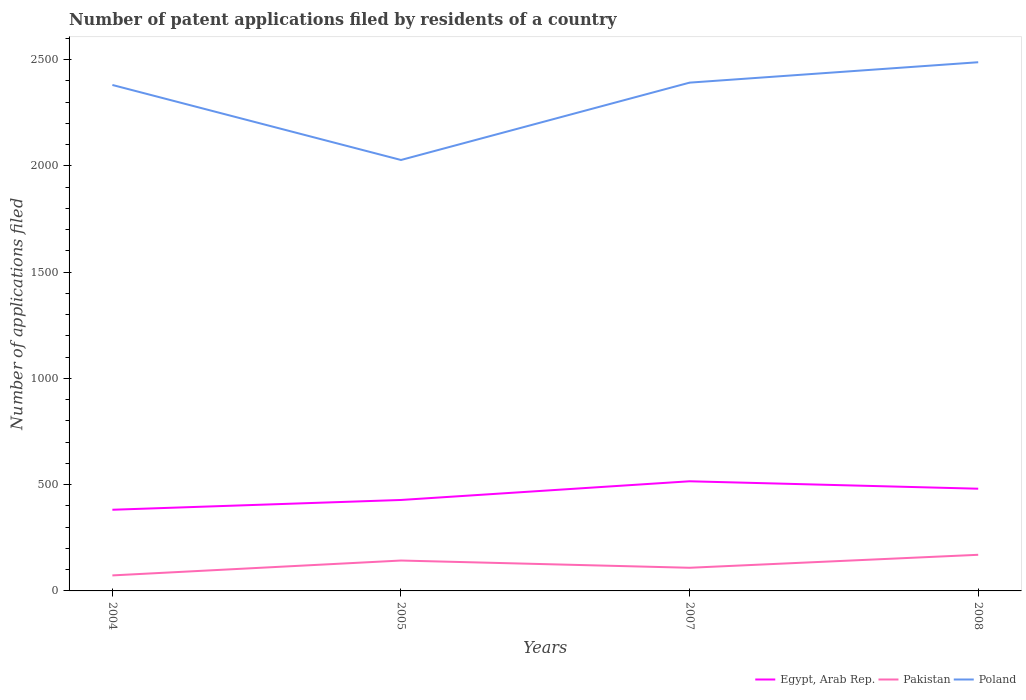How many different coloured lines are there?
Offer a very short reply. 3. Is the number of lines equal to the number of legend labels?
Keep it short and to the point. Yes. Across all years, what is the maximum number of applications filed in Poland?
Offer a terse response. 2028. In which year was the number of applications filed in Pakistan maximum?
Ensure brevity in your answer.  2004. What is the total number of applications filed in Egypt, Arab Rep. in the graph?
Your response must be concise. -134. What is the difference between the highest and the second highest number of applications filed in Egypt, Arab Rep.?
Make the answer very short. 134. What is the difference between the highest and the lowest number of applications filed in Pakistan?
Provide a succinct answer. 2. Is the number of applications filed in Egypt, Arab Rep. strictly greater than the number of applications filed in Pakistan over the years?
Your answer should be compact. No. Does the graph contain any zero values?
Ensure brevity in your answer.  No. Where does the legend appear in the graph?
Give a very brief answer. Bottom right. How many legend labels are there?
Your answer should be compact. 3. What is the title of the graph?
Give a very brief answer. Number of patent applications filed by residents of a country. Does "Lebanon" appear as one of the legend labels in the graph?
Your response must be concise. No. What is the label or title of the Y-axis?
Give a very brief answer. Number of applications filed. What is the Number of applications filed of Egypt, Arab Rep. in 2004?
Keep it short and to the point. 382. What is the Number of applications filed in Pakistan in 2004?
Provide a short and direct response. 73. What is the Number of applications filed in Poland in 2004?
Offer a very short reply. 2381. What is the Number of applications filed of Egypt, Arab Rep. in 2005?
Offer a terse response. 428. What is the Number of applications filed in Pakistan in 2005?
Make the answer very short. 143. What is the Number of applications filed of Poland in 2005?
Provide a short and direct response. 2028. What is the Number of applications filed of Egypt, Arab Rep. in 2007?
Your response must be concise. 516. What is the Number of applications filed in Pakistan in 2007?
Your answer should be very brief. 109. What is the Number of applications filed in Poland in 2007?
Offer a terse response. 2392. What is the Number of applications filed in Egypt, Arab Rep. in 2008?
Offer a very short reply. 481. What is the Number of applications filed in Pakistan in 2008?
Ensure brevity in your answer.  170. What is the Number of applications filed of Poland in 2008?
Provide a succinct answer. 2488. Across all years, what is the maximum Number of applications filed in Egypt, Arab Rep.?
Offer a terse response. 516. Across all years, what is the maximum Number of applications filed of Pakistan?
Ensure brevity in your answer.  170. Across all years, what is the maximum Number of applications filed of Poland?
Ensure brevity in your answer.  2488. Across all years, what is the minimum Number of applications filed of Egypt, Arab Rep.?
Your answer should be very brief. 382. Across all years, what is the minimum Number of applications filed in Pakistan?
Offer a terse response. 73. Across all years, what is the minimum Number of applications filed in Poland?
Provide a short and direct response. 2028. What is the total Number of applications filed of Egypt, Arab Rep. in the graph?
Your response must be concise. 1807. What is the total Number of applications filed in Pakistan in the graph?
Make the answer very short. 495. What is the total Number of applications filed in Poland in the graph?
Ensure brevity in your answer.  9289. What is the difference between the Number of applications filed of Egypt, Arab Rep. in 2004 and that in 2005?
Keep it short and to the point. -46. What is the difference between the Number of applications filed in Pakistan in 2004 and that in 2005?
Provide a succinct answer. -70. What is the difference between the Number of applications filed of Poland in 2004 and that in 2005?
Offer a very short reply. 353. What is the difference between the Number of applications filed of Egypt, Arab Rep. in 2004 and that in 2007?
Offer a terse response. -134. What is the difference between the Number of applications filed in Pakistan in 2004 and that in 2007?
Give a very brief answer. -36. What is the difference between the Number of applications filed in Poland in 2004 and that in 2007?
Provide a succinct answer. -11. What is the difference between the Number of applications filed in Egypt, Arab Rep. in 2004 and that in 2008?
Ensure brevity in your answer.  -99. What is the difference between the Number of applications filed in Pakistan in 2004 and that in 2008?
Keep it short and to the point. -97. What is the difference between the Number of applications filed in Poland in 2004 and that in 2008?
Your answer should be very brief. -107. What is the difference between the Number of applications filed in Egypt, Arab Rep. in 2005 and that in 2007?
Provide a short and direct response. -88. What is the difference between the Number of applications filed of Pakistan in 2005 and that in 2007?
Ensure brevity in your answer.  34. What is the difference between the Number of applications filed of Poland in 2005 and that in 2007?
Your answer should be compact. -364. What is the difference between the Number of applications filed in Egypt, Arab Rep. in 2005 and that in 2008?
Offer a terse response. -53. What is the difference between the Number of applications filed of Poland in 2005 and that in 2008?
Your answer should be compact. -460. What is the difference between the Number of applications filed in Pakistan in 2007 and that in 2008?
Give a very brief answer. -61. What is the difference between the Number of applications filed in Poland in 2007 and that in 2008?
Offer a very short reply. -96. What is the difference between the Number of applications filed of Egypt, Arab Rep. in 2004 and the Number of applications filed of Pakistan in 2005?
Offer a very short reply. 239. What is the difference between the Number of applications filed of Egypt, Arab Rep. in 2004 and the Number of applications filed of Poland in 2005?
Provide a short and direct response. -1646. What is the difference between the Number of applications filed of Pakistan in 2004 and the Number of applications filed of Poland in 2005?
Give a very brief answer. -1955. What is the difference between the Number of applications filed of Egypt, Arab Rep. in 2004 and the Number of applications filed of Pakistan in 2007?
Provide a short and direct response. 273. What is the difference between the Number of applications filed of Egypt, Arab Rep. in 2004 and the Number of applications filed of Poland in 2007?
Provide a succinct answer. -2010. What is the difference between the Number of applications filed of Pakistan in 2004 and the Number of applications filed of Poland in 2007?
Your answer should be very brief. -2319. What is the difference between the Number of applications filed of Egypt, Arab Rep. in 2004 and the Number of applications filed of Pakistan in 2008?
Make the answer very short. 212. What is the difference between the Number of applications filed of Egypt, Arab Rep. in 2004 and the Number of applications filed of Poland in 2008?
Provide a short and direct response. -2106. What is the difference between the Number of applications filed in Pakistan in 2004 and the Number of applications filed in Poland in 2008?
Your response must be concise. -2415. What is the difference between the Number of applications filed in Egypt, Arab Rep. in 2005 and the Number of applications filed in Pakistan in 2007?
Your response must be concise. 319. What is the difference between the Number of applications filed in Egypt, Arab Rep. in 2005 and the Number of applications filed in Poland in 2007?
Your response must be concise. -1964. What is the difference between the Number of applications filed in Pakistan in 2005 and the Number of applications filed in Poland in 2007?
Offer a terse response. -2249. What is the difference between the Number of applications filed of Egypt, Arab Rep. in 2005 and the Number of applications filed of Pakistan in 2008?
Give a very brief answer. 258. What is the difference between the Number of applications filed of Egypt, Arab Rep. in 2005 and the Number of applications filed of Poland in 2008?
Give a very brief answer. -2060. What is the difference between the Number of applications filed of Pakistan in 2005 and the Number of applications filed of Poland in 2008?
Keep it short and to the point. -2345. What is the difference between the Number of applications filed in Egypt, Arab Rep. in 2007 and the Number of applications filed in Pakistan in 2008?
Ensure brevity in your answer.  346. What is the difference between the Number of applications filed of Egypt, Arab Rep. in 2007 and the Number of applications filed of Poland in 2008?
Provide a short and direct response. -1972. What is the difference between the Number of applications filed of Pakistan in 2007 and the Number of applications filed of Poland in 2008?
Your response must be concise. -2379. What is the average Number of applications filed in Egypt, Arab Rep. per year?
Provide a short and direct response. 451.75. What is the average Number of applications filed of Pakistan per year?
Provide a short and direct response. 123.75. What is the average Number of applications filed in Poland per year?
Your response must be concise. 2322.25. In the year 2004, what is the difference between the Number of applications filed in Egypt, Arab Rep. and Number of applications filed in Pakistan?
Keep it short and to the point. 309. In the year 2004, what is the difference between the Number of applications filed of Egypt, Arab Rep. and Number of applications filed of Poland?
Provide a succinct answer. -1999. In the year 2004, what is the difference between the Number of applications filed in Pakistan and Number of applications filed in Poland?
Keep it short and to the point. -2308. In the year 2005, what is the difference between the Number of applications filed of Egypt, Arab Rep. and Number of applications filed of Pakistan?
Give a very brief answer. 285. In the year 2005, what is the difference between the Number of applications filed in Egypt, Arab Rep. and Number of applications filed in Poland?
Your answer should be very brief. -1600. In the year 2005, what is the difference between the Number of applications filed of Pakistan and Number of applications filed of Poland?
Ensure brevity in your answer.  -1885. In the year 2007, what is the difference between the Number of applications filed in Egypt, Arab Rep. and Number of applications filed in Pakistan?
Keep it short and to the point. 407. In the year 2007, what is the difference between the Number of applications filed in Egypt, Arab Rep. and Number of applications filed in Poland?
Give a very brief answer. -1876. In the year 2007, what is the difference between the Number of applications filed in Pakistan and Number of applications filed in Poland?
Offer a terse response. -2283. In the year 2008, what is the difference between the Number of applications filed in Egypt, Arab Rep. and Number of applications filed in Pakistan?
Offer a terse response. 311. In the year 2008, what is the difference between the Number of applications filed in Egypt, Arab Rep. and Number of applications filed in Poland?
Keep it short and to the point. -2007. In the year 2008, what is the difference between the Number of applications filed in Pakistan and Number of applications filed in Poland?
Your answer should be very brief. -2318. What is the ratio of the Number of applications filed in Egypt, Arab Rep. in 2004 to that in 2005?
Give a very brief answer. 0.89. What is the ratio of the Number of applications filed in Pakistan in 2004 to that in 2005?
Your answer should be very brief. 0.51. What is the ratio of the Number of applications filed of Poland in 2004 to that in 2005?
Ensure brevity in your answer.  1.17. What is the ratio of the Number of applications filed of Egypt, Arab Rep. in 2004 to that in 2007?
Your answer should be compact. 0.74. What is the ratio of the Number of applications filed in Pakistan in 2004 to that in 2007?
Make the answer very short. 0.67. What is the ratio of the Number of applications filed in Egypt, Arab Rep. in 2004 to that in 2008?
Offer a very short reply. 0.79. What is the ratio of the Number of applications filed in Pakistan in 2004 to that in 2008?
Provide a succinct answer. 0.43. What is the ratio of the Number of applications filed in Egypt, Arab Rep. in 2005 to that in 2007?
Ensure brevity in your answer.  0.83. What is the ratio of the Number of applications filed in Pakistan in 2005 to that in 2007?
Make the answer very short. 1.31. What is the ratio of the Number of applications filed in Poland in 2005 to that in 2007?
Keep it short and to the point. 0.85. What is the ratio of the Number of applications filed in Egypt, Arab Rep. in 2005 to that in 2008?
Provide a succinct answer. 0.89. What is the ratio of the Number of applications filed of Pakistan in 2005 to that in 2008?
Provide a short and direct response. 0.84. What is the ratio of the Number of applications filed of Poland in 2005 to that in 2008?
Provide a short and direct response. 0.82. What is the ratio of the Number of applications filed in Egypt, Arab Rep. in 2007 to that in 2008?
Give a very brief answer. 1.07. What is the ratio of the Number of applications filed of Pakistan in 2007 to that in 2008?
Provide a succinct answer. 0.64. What is the ratio of the Number of applications filed in Poland in 2007 to that in 2008?
Provide a short and direct response. 0.96. What is the difference between the highest and the second highest Number of applications filed of Egypt, Arab Rep.?
Offer a terse response. 35. What is the difference between the highest and the second highest Number of applications filed in Poland?
Your response must be concise. 96. What is the difference between the highest and the lowest Number of applications filed of Egypt, Arab Rep.?
Provide a succinct answer. 134. What is the difference between the highest and the lowest Number of applications filed of Pakistan?
Offer a very short reply. 97. What is the difference between the highest and the lowest Number of applications filed in Poland?
Your answer should be very brief. 460. 